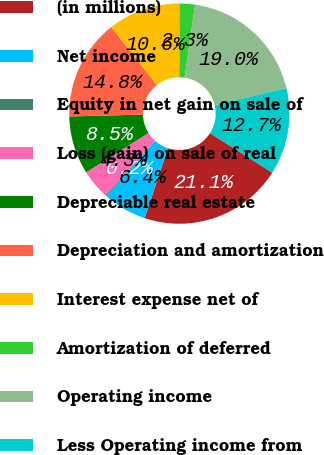Convert chart to OTSL. <chart><loc_0><loc_0><loc_500><loc_500><pie_chart><fcel>(in millions)<fcel>Net income<fcel>Equity in net gain on sale of<fcel>Loss (gain) on sale of real<fcel>Depreciable real estate<fcel>Depreciation and amortization<fcel>Interest expense net of<fcel>Amortization of deferred<fcel>Operating income<fcel>Less Operating income from<nl><fcel>21.09%<fcel>6.44%<fcel>0.17%<fcel>4.35%<fcel>8.54%<fcel>14.81%<fcel>10.63%<fcel>2.26%<fcel>18.99%<fcel>12.72%<nl></chart> 